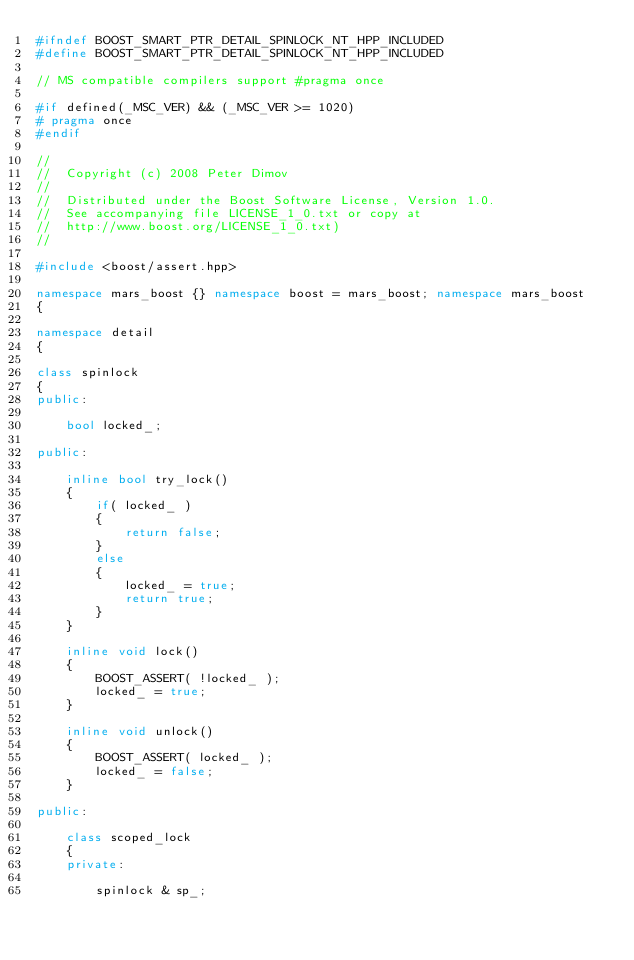<code> <loc_0><loc_0><loc_500><loc_500><_C++_>#ifndef BOOST_SMART_PTR_DETAIL_SPINLOCK_NT_HPP_INCLUDED
#define BOOST_SMART_PTR_DETAIL_SPINLOCK_NT_HPP_INCLUDED

// MS compatible compilers support #pragma once

#if defined(_MSC_VER) && (_MSC_VER >= 1020)
# pragma once
#endif

//
//  Copyright (c) 2008 Peter Dimov
//
//  Distributed under the Boost Software License, Version 1.0.
//  See accompanying file LICENSE_1_0.txt or copy at
//  http://www.boost.org/LICENSE_1_0.txt)
//

#include <boost/assert.hpp>

namespace mars_boost {} namespace boost = mars_boost; namespace mars_boost
{

namespace detail
{

class spinlock
{
public:

    bool locked_;

public:

    inline bool try_lock()
    {
        if( locked_ )
        {
            return false;
        }
        else
        {
            locked_ = true;
            return true;
        }
    }

    inline void lock()
    {
        BOOST_ASSERT( !locked_ );
        locked_ = true;
    }

    inline void unlock()
    {
        BOOST_ASSERT( locked_ );
        locked_ = false;
    }

public:

    class scoped_lock
    {
    private:

        spinlock & sp_;
</code> 